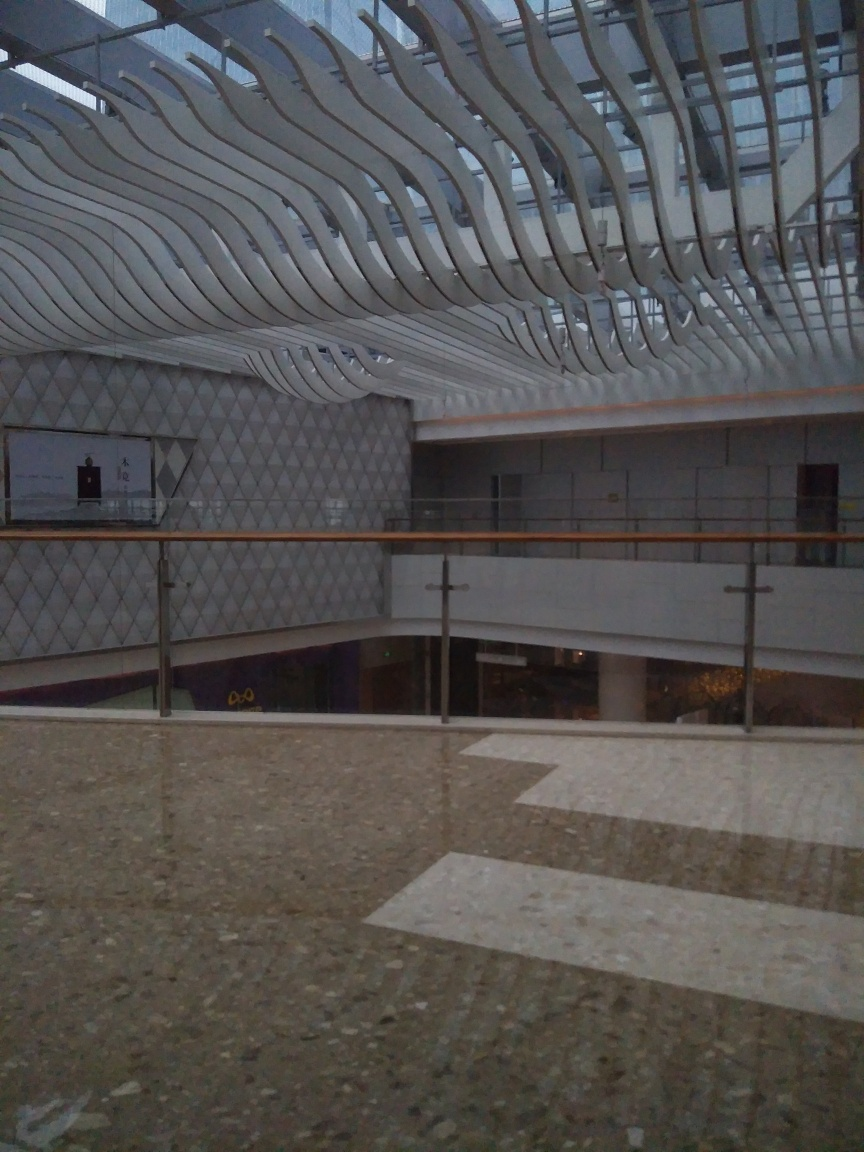This image seems quite dim, can you suggest how it might be improved? To improve the lighting in this image, increasing the exposure either by adjusting the camera settings or post-processing would help illuminate the details more clearly. Using a lower ISO setting or a slower shutter speed with a stable tripod could reduce the graininess and achieve a sharper result. If the opportunity for a retake exists, doing so during the time of day when natural light is more abundant or with additional artificial lighting would significantly enhance the image quality. 